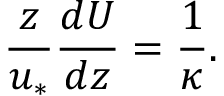Convert formula to latex. <formula><loc_0><loc_0><loc_500><loc_500>\frac { z } { u _ { \ast } } \frac { d U } { d z } = \frac { 1 } { \kappa } .</formula> 